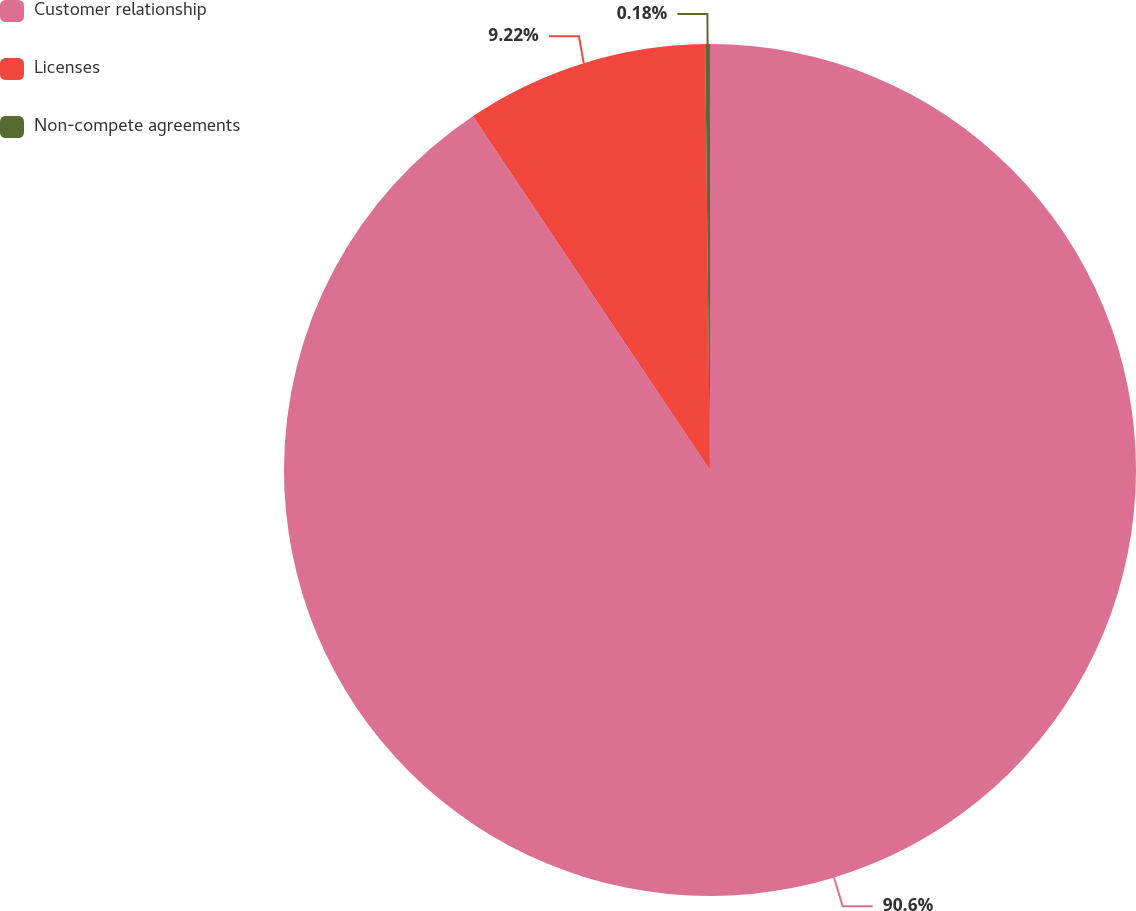Convert chart to OTSL. <chart><loc_0><loc_0><loc_500><loc_500><pie_chart><fcel>Customer relationship<fcel>Licenses<fcel>Non-compete agreements<nl><fcel>90.6%<fcel>9.22%<fcel>0.18%<nl></chart> 